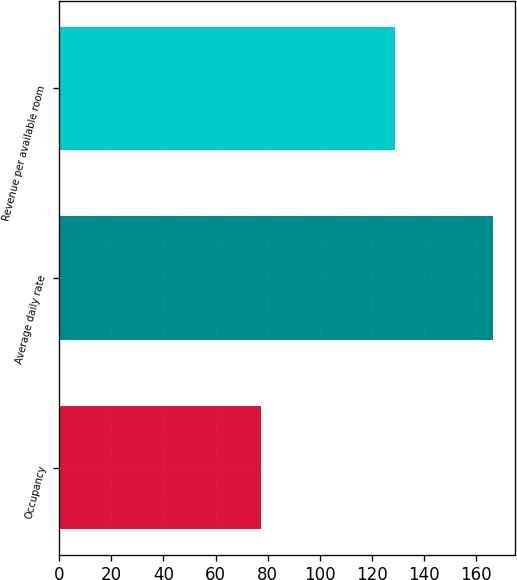Convert chart to OTSL. <chart><loc_0><loc_0><loc_500><loc_500><bar_chart><fcel>Occupancy<fcel>Average daily rate<fcel>Revenue per available room<nl><fcel>77.3<fcel>166.4<fcel>128.78<nl></chart> 